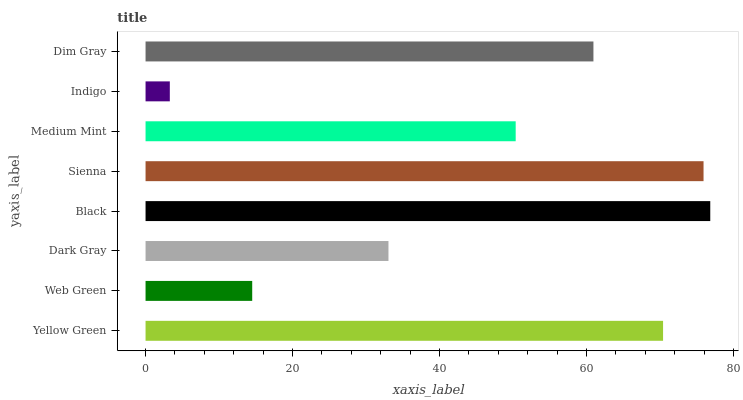Is Indigo the minimum?
Answer yes or no. Yes. Is Black the maximum?
Answer yes or no. Yes. Is Web Green the minimum?
Answer yes or no. No. Is Web Green the maximum?
Answer yes or no. No. Is Yellow Green greater than Web Green?
Answer yes or no. Yes. Is Web Green less than Yellow Green?
Answer yes or no. Yes. Is Web Green greater than Yellow Green?
Answer yes or no. No. Is Yellow Green less than Web Green?
Answer yes or no. No. Is Dim Gray the high median?
Answer yes or no. Yes. Is Medium Mint the low median?
Answer yes or no. Yes. Is Black the high median?
Answer yes or no. No. Is Dim Gray the low median?
Answer yes or no. No. 